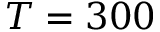<formula> <loc_0><loc_0><loc_500><loc_500>T = 3 0 0</formula> 